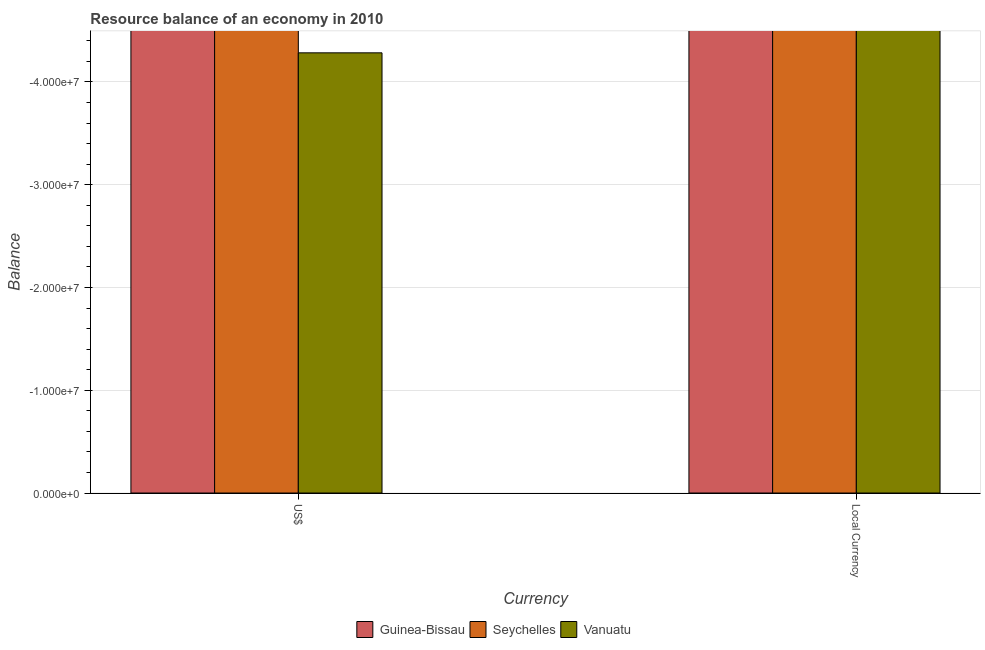Are the number of bars per tick equal to the number of legend labels?
Keep it short and to the point. No. Are the number of bars on each tick of the X-axis equal?
Your response must be concise. Yes. How many bars are there on the 1st tick from the left?
Provide a succinct answer. 0. What is the label of the 1st group of bars from the left?
Make the answer very short. US$. What is the total resource balance in us$ in the graph?
Provide a succinct answer. 0. What is the average resource balance in constant us$ per country?
Provide a succinct answer. 0. In how many countries, is the resource balance in constant us$ greater than -34000000 units?
Your response must be concise. 0. How many countries are there in the graph?
Your response must be concise. 3. What is the difference between two consecutive major ticks on the Y-axis?
Ensure brevity in your answer.  1.00e+07. Are the values on the major ticks of Y-axis written in scientific E-notation?
Make the answer very short. Yes. Does the graph contain any zero values?
Your answer should be compact. Yes. Does the graph contain grids?
Ensure brevity in your answer.  Yes. Where does the legend appear in the graph?
Offer a terse response. Bottom center. How many legend labels are there?
Your response must be concise. 3. What is the title of the graph?
Offer a terse response. Resource balance of an economy in 2010. Does "St. Kitts and Nevis" appear as one of the legend labels in the graph?
Provide a succinct answer. No. What is the label or title of the X-axis?
Offer a very short reply. Currency. What is the label or title of the Y-axis?
Ensure brevity in your answer.  Balance. What is the Balance in Vanuatu in US$?
Your response must be concise. 0. What is the Balance in Seychelles in Local Currency?
Provide a succinct answer. 0. What is the Balance in Vanuatu in Local Currency?
Provide a short and direct response. 0. What is the average Balance of Seychelles per Currency?
Offer a terse response. 0. What is the average Balance in Vanuatu per Currency?
Your response must be concise. 0. 